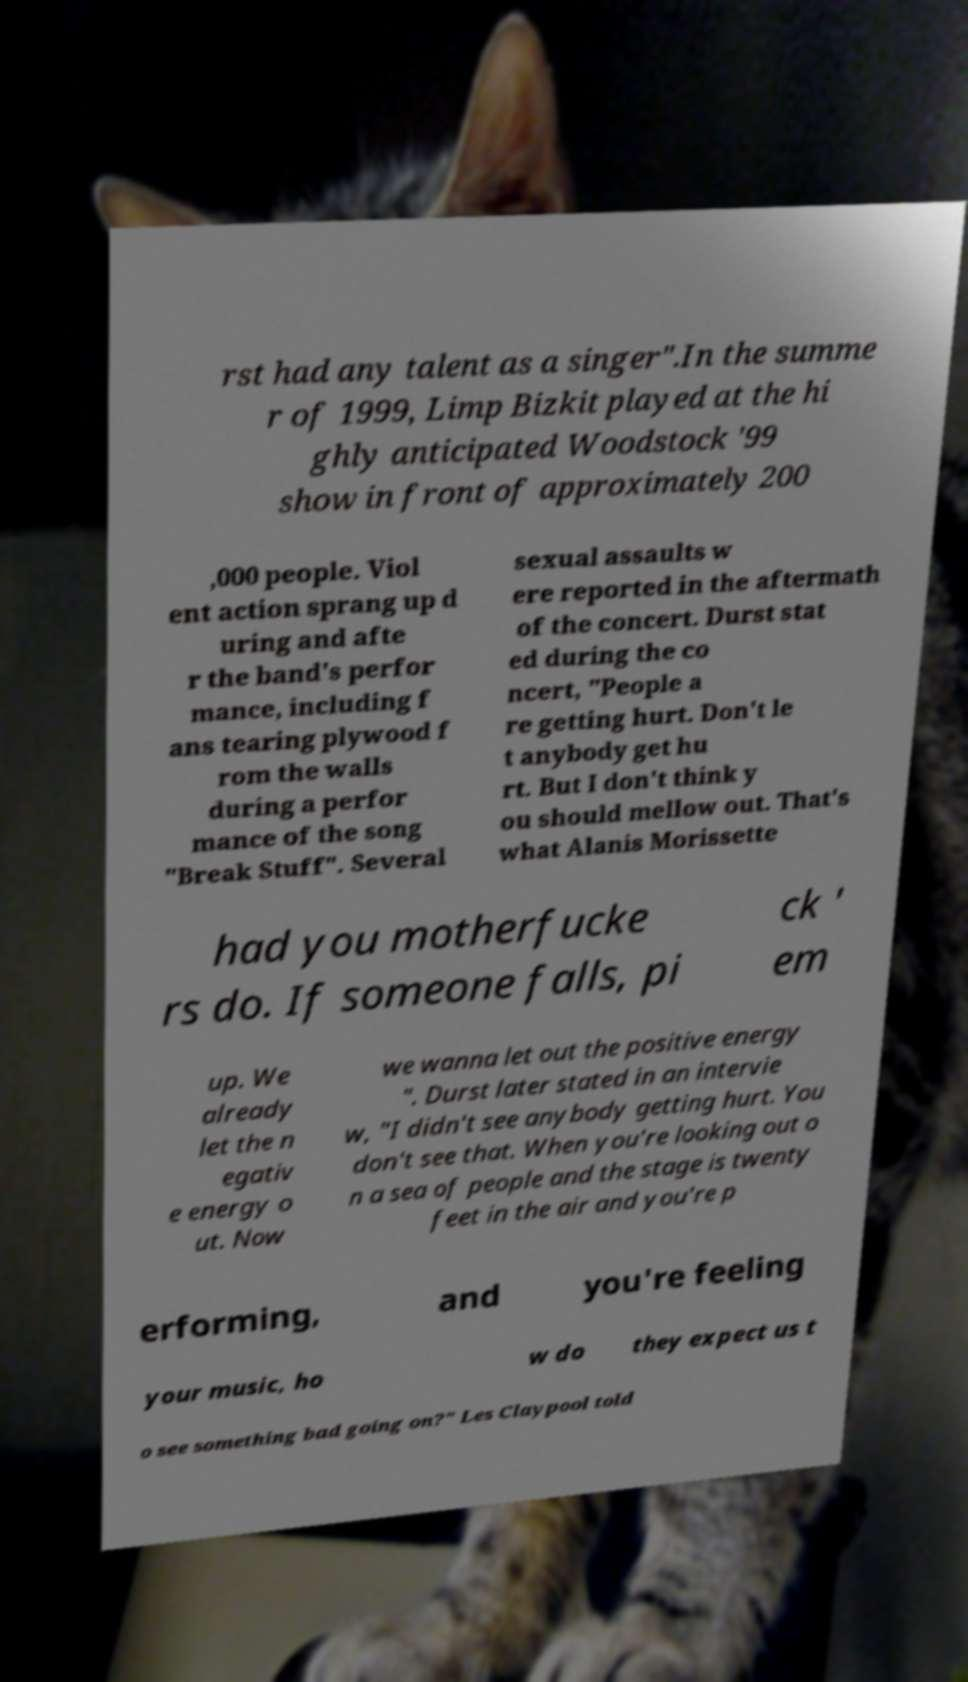Please read and relay the text visible in this image. What does it say? rst had any talent as a singer".In the summe r of 1999, Limp Bizkit played at the hi ghly anticipated Woodstock '99 show in front of approximately 200 ,000 people. Viol ent action sprang up d uring and afte r the band's perfor mance, including f ans tearing plywood f rom the walls during a perfor mance of the song "Break Stuff". Several sexual assaults w ere reported in the aftermath of the concert. Durst stat ed during the co ncert, "People a re getting hurt. Don't le t anybody get hu rt. But I don't think y ou should mellow out. That's what Alanis Morissette had you motherfucke rs do. If someone falls, pi ck ' em up. We already let the n egativ e energy o ut. Now we wanna let out the positive energy ". Durst later stated in an intervie w, "I didn't see anybody getting hurt. You don't see that. When you're looking out o n a sea of people and the stage is twenty feet in the air and you're p erforming, and you're feeling your music, ho w do they expect us t o see something bad going on?" Les Claypool told 